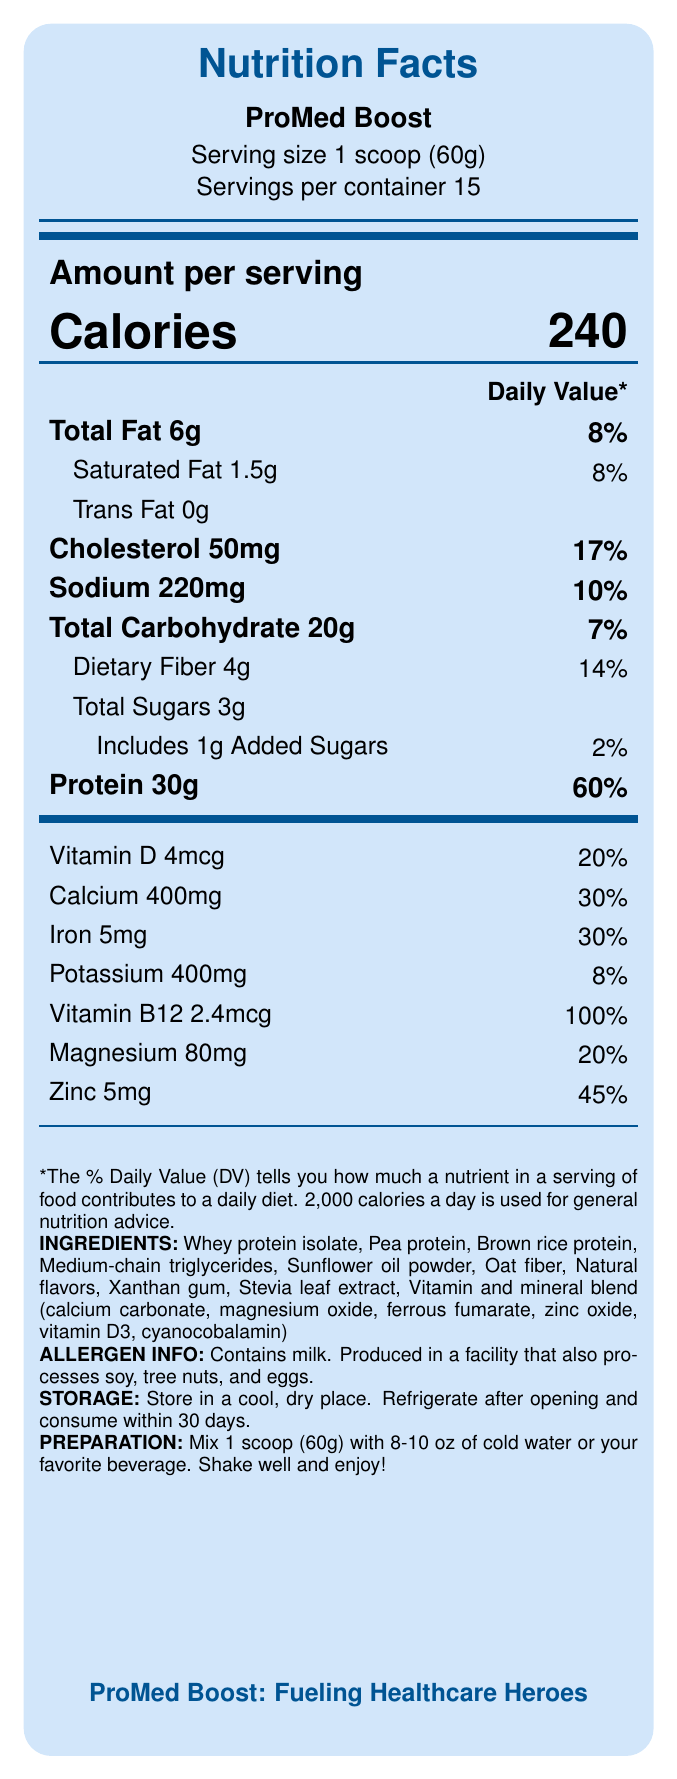how many calories are in one serving of ProMed Boost? The document specifies that one serving, which is 1 scoop (60g), contains 240 calories.
Answer: 240 what is the serving size of ProMed Boost? The serving size is stated as 1 scoop (60g).
Answer: 1 scoop (60g) how many grams of protein are in each serving of ProMed Boost? The nutrition label specifies that each serving contains 30g of protein.
Answer: 30g what percentage of the Daily Value of vitamin B12 does one serving of ProMed Boost provide? The document indicates that one serving provides 100% of the Daily Value for vitamin B12.
Answer: 100% how many servings are there per container? The document mentions that there are 15 servings per container.
Answer: 15 The amount of dietary fiber in each serving is: A. 2g B. 4g C. 5g D. 8g The document specifies that each serving contains 4g of dietary fiber.
Answer: B. 4g what are the first three ingredients listed on the ProMed Boost label? The first three ingredients listed are Whey protein isolate, Pea protein, and Brown rice protein.
Answer: Whey protein isolate, Pea protein, Brown rice protein what is the percentage of the Daily Value for calcium in one serving? The document indicates that one serving contains 30% of the Daily Value for calcium.
Answer: 30% ProMed Boost is low in sugar: True or False? The document states that ProMed Boost is low in sugar, containing only 3g of total sugars per serving.
Answer: True describe the main idea of the document. The main idea is that ProMed Boost is a meal replacement shake that provides comprehensive nutrition to support busy healthcare professionals, with a focus on protein, essential vitamins, and minerals.
Answer: The document provides the nutrition facts and additional information for a high-protein meal replacement shake called ProMed Boost, designed for busy healthcare professionals. It highlights the nutritional content, such as calories, protein, fats, carbohydrates, vitamins, and minerals per serving. It also includes ingredient lists, allergen information, storage and preparation instructions, and marketing claims emphasizing its benefits for muscle recovery, sustained energy, and immune support. how much iron does one serving of ProMed Boost contain? The document states that one serving contains 5mg of iron.
Answer: 5mg the primary claim made by the product's marketing is: A. Low in carbohydrates B. High in antioxidants C. Designed for busy healthcare professionals D. Gluten-free The primary marketing claim highlighted is that the product is designed for busy healthcare professionals.
Answer: C. Designed for busy healthcare professionals how many grams of saturated fat are in each serving? The document indicates that each serving contains 1.5g of saturated fat.
Answer: 1.5g what is the storage instruction for ProMed Boost after opening? The document advises to refrigerate the product after opening and consume it within 30 days.
Answer: Refrigerate after opening and consume within 30 days Can you consume ProMed Boost if you are allergic to tree nuts? The document states that ProMed Boost is produced in a facility that also processes soy, tree nuts, and eggs, so there could be a risk of cross-contamination.
Answer: It cannot be determined 